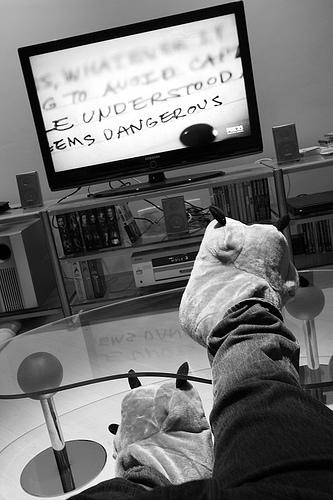Analyze the flooring in the image and describe its material and appearance. The flooring is made of wood with visible grain patterns, giving it a warm and natural look. Examine the image for any potential safety hazards or issues. Cables behind the TV stand are exposed and could be a tripping hazard or cause electrical issues if not properly organized or secured. Determine the mood or sentiment in the image based on the objects and environment. The mood in the image is nostalgic and cozy, given the presence of VHS tapes, a classic TV, and a comfortable-looking slipper. Count the total number of portable speakers in the image. There are three portable speakers in the image. Explain the appearance and content displayed on the TV screen. The TV screen is showing a black and white photo of a person in a room, with the words "dangerous wod" displayed on it. Name two objects or items that are reflecting off the glass surface of the table. The TV screen and the words "dangerous wod" are reflecting off the glass surface of the table. Please provide a detailed description of the jeans worn by the person sitting down. The jeans are gray in color with a slightly worn appearance, fitting snugly around the person's legs as they sit with one leg on the table. Identify the type of slipper in the image and describe its unique features. The slipper is a furry animal slipper with claw-like features, giving it a fun and playful appearance. Point out three different objects that are on or under the glass table. A ball, a set of DVDs, and a person's leg. What type of electronics are on the metal frame shelves? VHS movie tapes, dvd players, a speaker, and a portable speaker. 